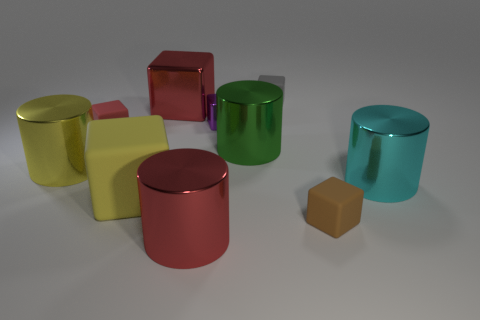Subtract all yellow cylinders. How many cylinders are left? 3 Subtract all brown cubes. How many cubes are left? 5 Subtract all yellow cubes. Subtract all red spheres. How many cubes are left? 5 Subtract all cylinders. How many objects are left? 6 Add 9 purple metallic things. How many purple metallic things are left? 10 Add 1 tiny gray matte blocks. How many tiny gray matte blocks exist? 2 Subtract 0 yellow spheres. How many objects are left? 10 Subtract all rubber cubes. Subtract all gray matte spheres. How many objects are left? 6 